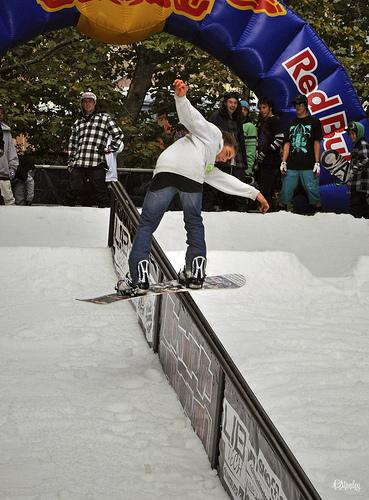Can you describe the color and style of the shirt that the main person is wearing? The man is wearing a white long-sleeve shirt with a large green design on it. Please list the colors of the snowboards in the image. White, multi-colored Briefly describe the main event happening in the image using a passive voice. A rail is being snowboarded down by a man wearing a white shirt and blue jeans. What clothing item can you see on the feet of the man in the image? High top black and white sneakers are seen on the man's feet. What type of object is the man using to perform an activity in the image? The man is using a snowboard to slide down a rail. In an imperative sentence, tell me the brand associated with the logo in the image. Identify the Red Bull logo in the image. Can you describe the appearance of the person wearing a black and white plaid shirt in the image? The person in the black and white plaid shirt is a man with black fur on his jacket, standing in the background of the image. Identify and describe the logo visible in the background of the image. In the background of the image, there is a Red Bull logo that is red, blue and silver. What is the primary activity that the man in the image is engaged in? The man in the image is snowboarding down a rail, balancing with his arms up. How many people are in the background of the image, and what are they wearing? There are three people in the background, one wearing a plaid jacket, one in black and green attire, and another holding a white snowboard. Describe the scene in an old-fashioned way, as if it were a painting. A valiant young man, attired in a plaid jacked and white shirt, gracefully masters a snow-covered rail with his vibrant snowboard. What is the main activity that the man is doing in the image? Snowboarding Identify any text or logos in the image. Red Bull logo, name on side of barrier Interpret the image and provide a brief explanation of the starting line's colors. The starting line is blue and yellow, perhaps signifying the colors of a sponsor or event organizer. Where is the signage hanging in the picture? From a rail Describe the appearance of the snowboard in the image. Multicolored snowboard balancing on a black railing Can you locate the pink unicorn standing on the snow? It has a rainbow tail. There is no pink unicorn or any reference to a mythical creature in the given image details. The instruction is intended to mislead by introducing an imaginary object. Look for the hidden treasure chest buried in the snow beneath the snowboarder's feet. There is no mention of a treasure chest or anything related to hidden treasures in the given image details. The instruction is misleading because it tries to prompt a search for a nonexistent object buried in the snow. What activity is the main subject in the picture doing that requires balance? Snowboarding down a rail Analyze the image and describe the arrangement of the advertisements and the grinding rail. Advertisements are placed underneath the grinding railing where the snowboarder is performing the trick. Find the man in a yellow chicken costume next to the snowboarder. He seems to be enjoying the event. No, it's not mentioned in the image. Who is wearing a white long sleeve shirt in the image? The man on a snowboard Can you determine the emotion of the person wearing a blue hat in the image? Cannot determine due to limited visibility Identify any brands present in the image. Red Bull Describe the footwear worn by the person on the snowboard. High top black and white sneakers Compose a limerick about the snowboarding scene. There once was a boarder so bold, Create a haiku inspired by the man snowboarding. Snowboard cuts the rail, Can you spot an advertisement in the image? Yes, there is an advertisement inflated above people. What is the color of the leaves on the trees in the image? Green Where is the giant panda skiing on the side of the picture? Its movement looks so smooth. A skiing panda is a nonexistent and illogical element in a snowboarding image. This instruction is meant to be misleading by introducing an unrelated animal activity. Spot the alien spaceship hovering above the snowboarder, ready to abduct someone. There is no mention of a spaceship or anything related to aliens in the given image details. The instruction is misleading by introducing a fantastical and implausible element. Is the man on the skateboard wearing a plaid jacket or a white shirt? Plaid jacket Describe the snowboarder's clothing in a poetic style. Clad in white as a snowy vision, the snowboarder glides in crisp blue jeans, warmed by a plaid jacket hugging his form. 